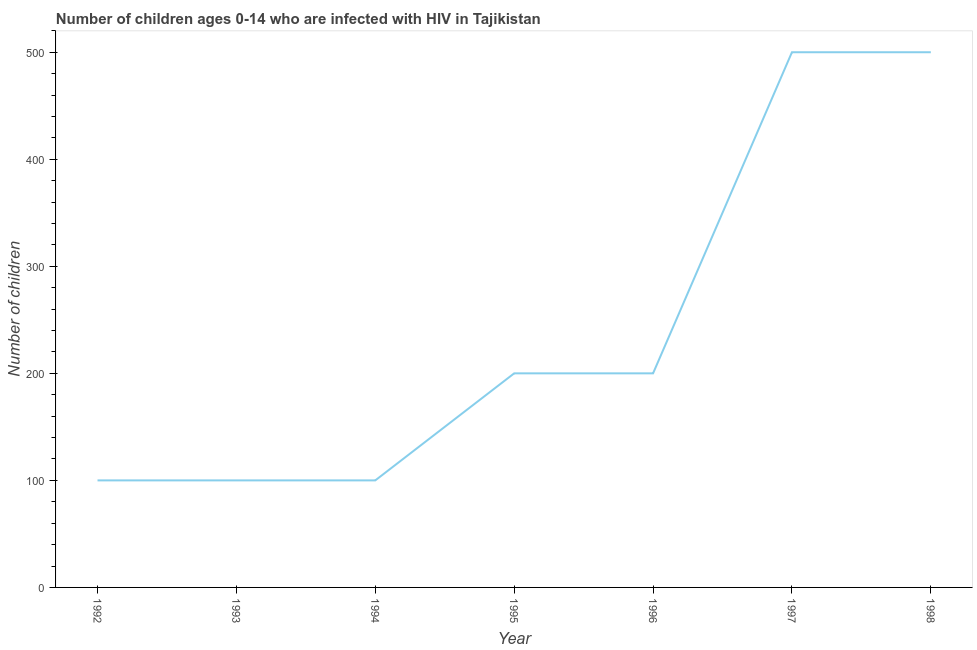What is the number of children living with hiv in 1998?
Ensure brevity in your answer.  500. Across all years, what is the maximum number of children living with hiv?
Your answer should be very brief. 500. Across all years, what is the minimum number of children living with hiv?
Keep it short and to the point. 100. In which year was the number of children living with hiv minimum?
Keep it short and to the point. 1992. What is the sum of the number of children living with hiv?
Make the answer very short. 1700. What is the difference between the number of children living with hiv in 1996 and 1997?
Give a very brief answer. -300. What is the average number of children living with hiv per year?
Your answer should be compact. 242.86. Do a majority of the years between 1996 and 1992 (inclusive) have number of children living with hiv greater than 200 ?
Offer a very short reply. Yes. What is the ratio of the number of children living with hiv in 1995 to that in 1998?
Provide a succinct answer. 0.4. Is the difference between the number of children living with hiv in 1994 and 1995 greater than the difference between any two years?
Provide a short and direct response. No. What is the difference between the highest and the second highest number of children living with hiv?
Give a very brief answer. 0. What is the difference between the highest and the lowest number of children living with hiv?
Provide a short and direct response. 400. In how many years, is the number of children living with hiv greater than the average number of children living with hiv taken over all years?
Keep it short and to the point. 2. Does the number of children living with hiv monotonically increase over the years?
Ensure brevity in your answer.  No. How many years are there in the graph?
Ensure brevity in your answer.  7. Does the graph contain any zero values?
Provide a succinct answer. No. What is the title of the graph?
Offer a very short reply. Number of children ages 0-14 who are infected with HIV in Tajikistan. What is the label or title of the X-axis?
Your response must be concise. Year. What is the label or title of the Y-axis?
Make the answer very short. Number of children. What is the Number of children of 1992?
Offer a very short reply. 100. What is the difference between the Number of children in 1992 and 1993?
Make the answer very short. 0. What is the difference between the Number of children in 1992 and 1995?
Provide a succinct answer. -100. What is the difference between the Number of children in 1992 and 1996?
Offer a very short reply. -100. What is the difference between the Number of children in 1992 and 1997?
Provide a succinct answer. -400. What is the difference between the Number of children in 1992 and 1998?
Your response must be concise. -400. What is the difference between the Number of children in 1993 and 1995?
Provide a succinct answer. -100. What is the difference between the Number of children in 1993 and 1996?
Give a very brief answer. -100. What is the difference between the Number of children in 1993 and 1997?
Your answer should be compact. -400. What is the difference between the Number of children in 1993 and 1998?
Provide a short and direct response. -400. What is the difference between the Number of children in 1994 and 1995?
Your answer should be compact. -100. What is the difference between the Number of children in 1994 and 1996?
Keep it short and to the point. -100. What is the difference between the Number of children in 1994 and 1997?
Provide a short and direct response. -400. What is the difference between the Number of children in 1994 and 1998?
Your response must be concise. -400. What is the difference between the Number of children in 1995 and 1996?
Provide a succinct answer. 0. What is the difference between the Number of children in 1995 and 1997?
Offer a very short reply. -300. What is the difference between the Number of children in 1995 and 1998?
Give a very brief answer. -300. What is the difference between the Number of children in 1996 and 1997?
Offer a very short reply. -300. What is the difference between the Number of children in 1996 and 1998?
Keep it short and to the point. -300. What is the difference between the Number of children in 1997 and 1998?
Make the answer very short. 0. What is the ratio of the Number of children in 1992 to that in 1993?
Provide a succinct answer. 1. What is the ratio of the Number of children in 1992 to that in 1994?
Ensure brevity in your answer.  1. What is the ratio of the Number of children in 1992 to that in 1997?
Your response must be concise. 0.2. What is the ratio of the Number of children in 1993 to that in 1994?
Your response must be concise. 1. What is the ratio of the Number of children in 1993 to that in 1995?
Offer a very short reply. 0.5. What is the ratio of the Number of children in 1993 to that in 1996?
Keep it short and to the point. 0.5. What is the ratio of the Number of children in 1993 to that in 1997?
Offer a very short reply. 0.2. What is the ratio of the Number of children in 1993 to that in 1998?
Your answer should be very brief. 0.2. What is the ratio of the Number of children in 1994 to that in 1996?
Keep it short and to the point. 0.5. What is the ratio of the Number of children in 1994 to that in 1997?
Keep it short and to the point. 0.2. What is the ratio of the Number of children in 1994 to that in 1998?
Ensure brevity in your answer.  0.2. What is the ratio of the Number of children in 1995 to that in 1998?
Your answer should be compact. 0.4. What is the ratio of the Number of children in 1996 to that in 1997?
Offer a very short reply. 0.4. 